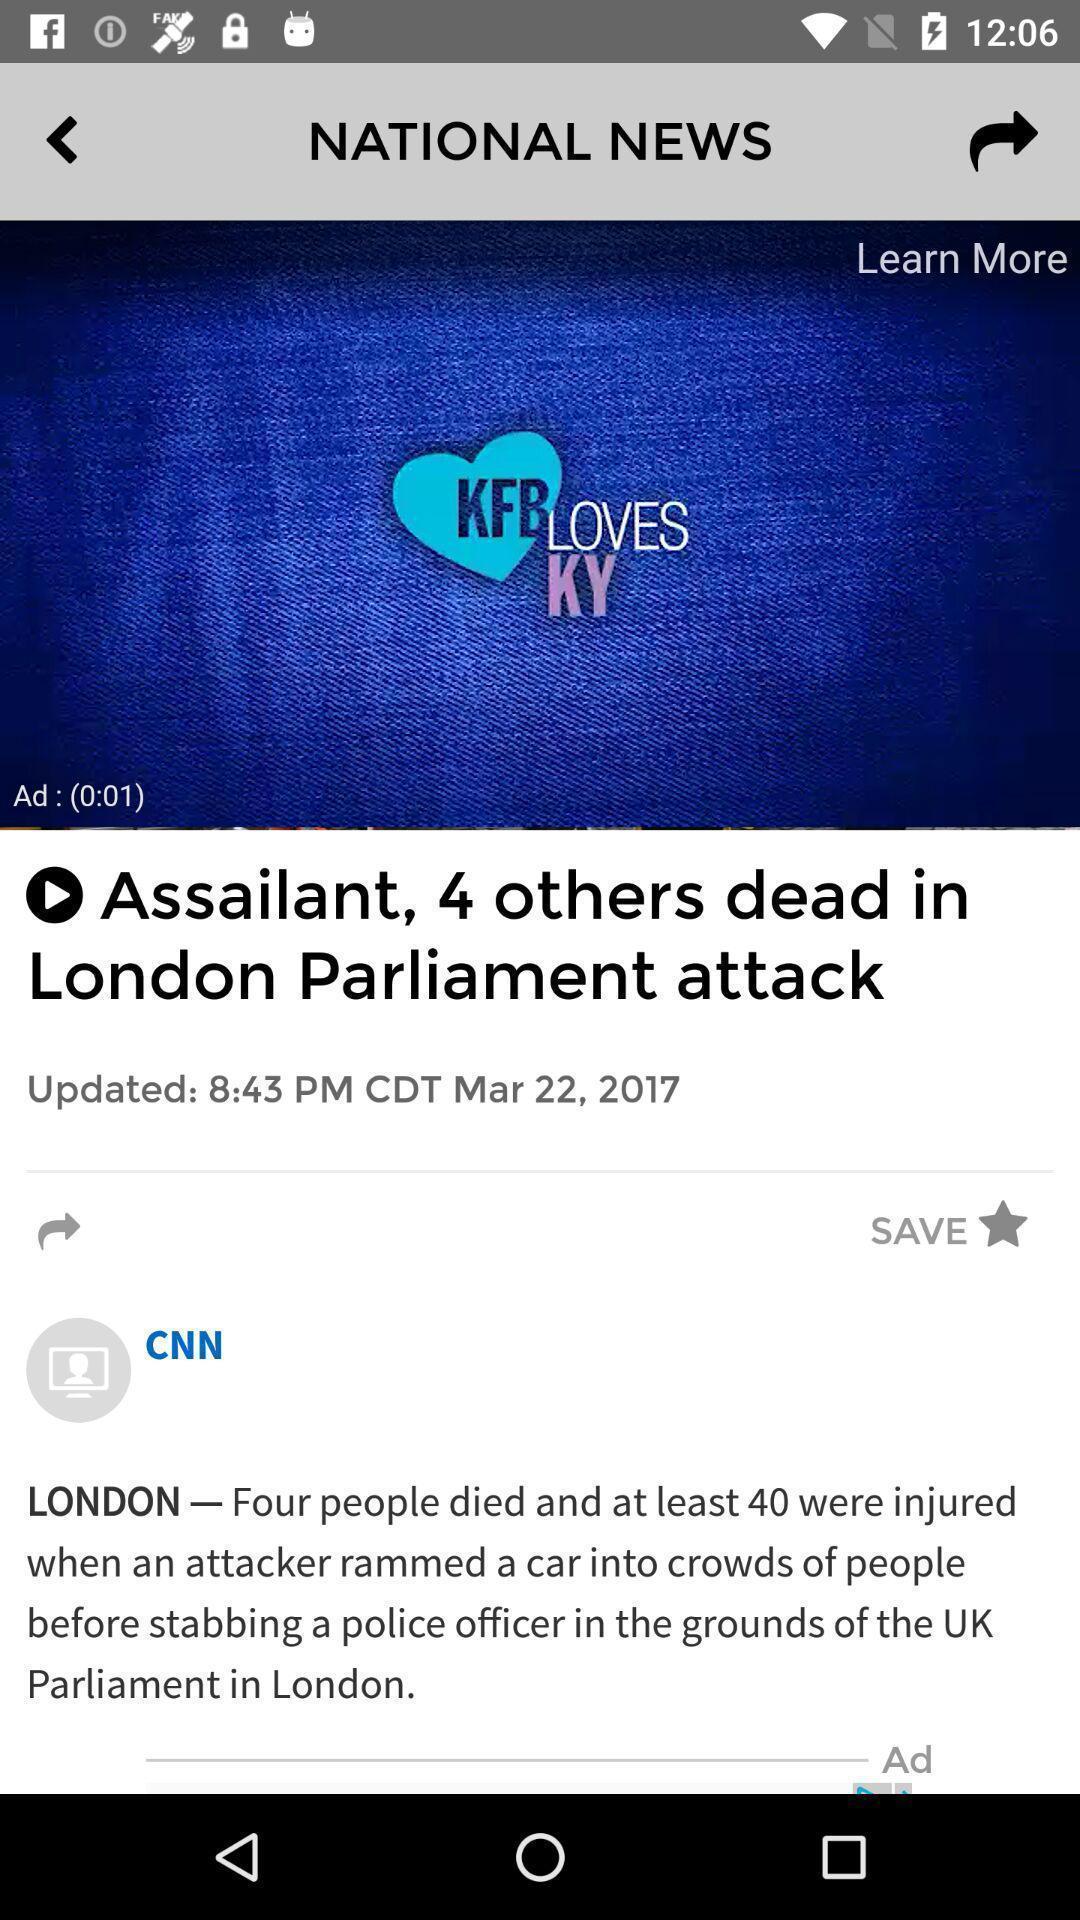Explain what's happening in this screen capture. Window displaying about news articles. 